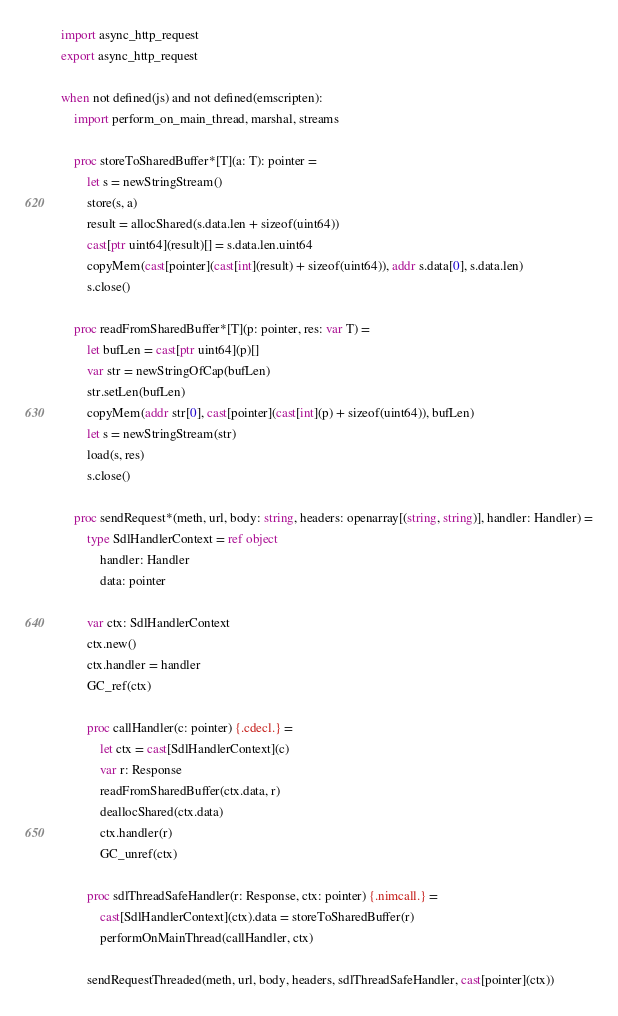Convert code to text. <code><loc_0><loc_0><loc_500><loc_500><_Nim_>import async_http_request
export async_http_request

when not defined(js) and not defined(emscripten):
    import perform_on_main_thread, marshal, streams

    proc storeToSharedBuffer*[T](a: T): pointer =
        let s = newStringStream()
        store(s, a)
        result = allocShared(s.data.len + sizeof(uint64))
        cast[ptr uint64](result)[] = s.data.len.uint64
        copyMem(cast[pointer](cast[int](result) + sizeof(uint64)), addr s.data[0], s.data.len)
        s.close()

    proc readFromSharedBuffer*[T](p: pointer, res: var T) =
        let bufLen = cast[ptr uint64](p)[]
        var str = newStringOfCap(bufLen)
        str.setLen(bufLen)
        copyMem(addr str[0], cast[pointer](cast[int](p) + sizeof(uint64)), bufLen)
        let s = newStringStream(str)
        load(s, res)
        s.close()

    proc sendRequest*(meth, url, body: string, headers: openarray[(string, string)], handler: Handler) =
        type SdlHandlerContext = ref object
            handler: Handler
            data: pointer

        var ctx: SdlHandlerContext
        ctx.new()
        ctx.handler = handler
        GC_ref(ctx)

        proc callHandler(c: pointer) {.cdecl.} =
            let ctx = cast[SdlHandlerContext](c)
            var r: Response
            readFromSharedBuffer(ctx.data, r)
            deallocShared(ctx.data)
            ctx.handler(r)
            GC_unref(ctx)

        proc sdlThreadSafeHandler(r: Response, ctx: pointer) {.nimcall.} =
            cast[SdlHandlerContext](ctx).data = storeToSharedBuffer(r)
            performOnMainThread(callHandler, ctx)

        sendRequestThreaded(meth, url, body, headers, sdlThreadSafeHandler, cast[pointer](ctx))
</code> 